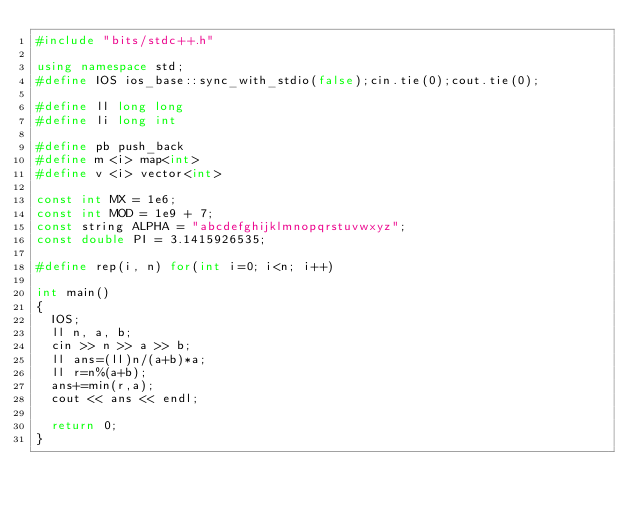Convert code to text. <code><loc_0><loc_0><loc_500><loc_500><_C++_>#include "bits/stdc++.h"

using namespace std;
#define IOS ios_base::sync_with_stdio(false);cin.tie(0);cout.tie(0);

#define ll long long
#define li long int

#define pb push_back
#define m <i> map<int>
#define v <i> vector<int>

const int MX = 1e6;
const int MOD = 1e9 + 7;
const string ALPHA = "abcdefghijklmnopqrstuvwxyz";
const double PI = 3.1415926535;

#define rep(i, n) for(int i=0; i<n; i++)

int main()
{
  IOS;
  ll n, a, b;
  cin >> n >> a >> b;
  ll ans=(ll)n/(a+b)*a;
  ll r=n%(a+b);
  ans+=min(r,a);
  cout << ans << endl;
  
  return 0;
}
</code> 